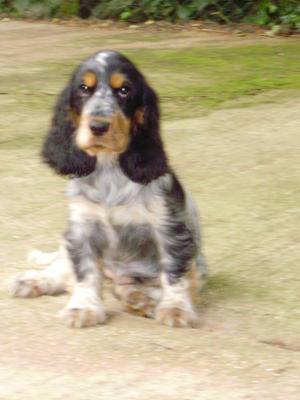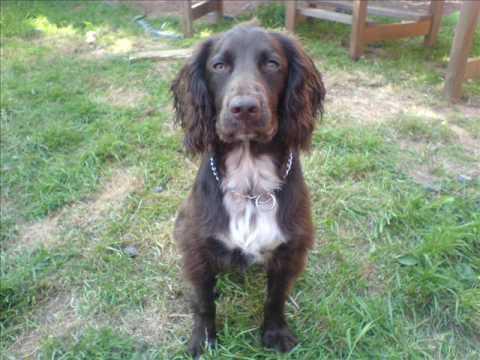The first image is the image on the left, the second image is the image on the right. For the images displayed, is the sentence "A human hand is holding a puppy in the air in one image, and no image contains more than one dog." factually correct? Answer yes or no. No. The first image is the image on the left, the second image is the image on the right. Considering the images on both sides, is "A person is holding a dog in at least one of the images." valid? Answer yes or no. No. 